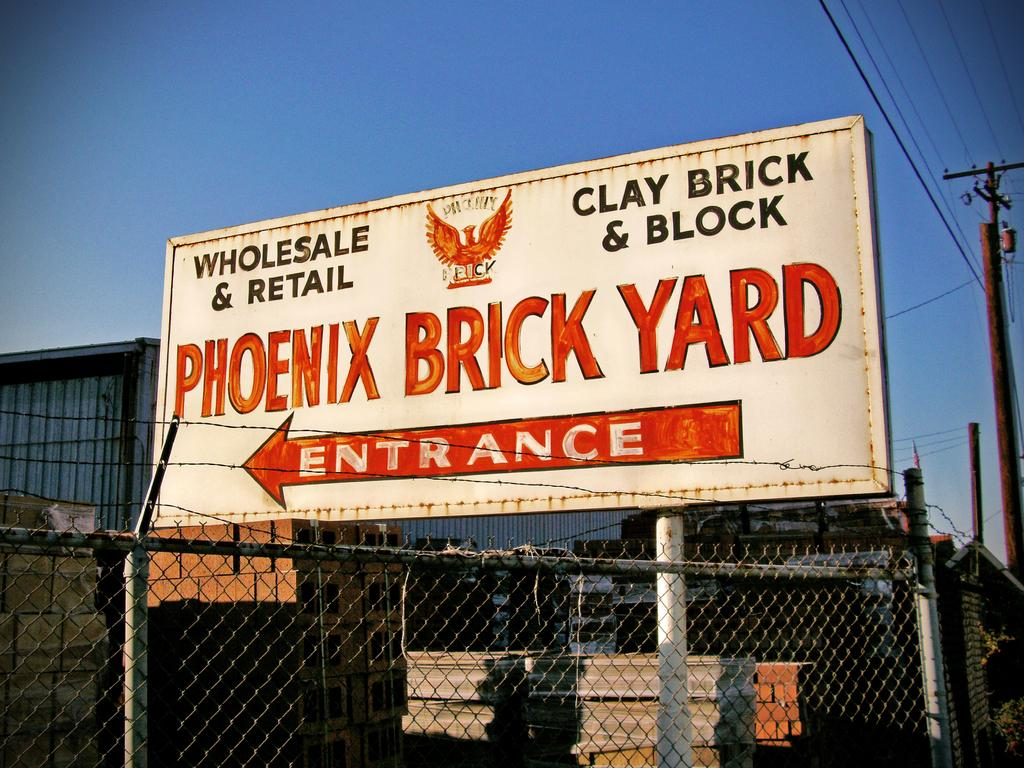<image>
Write a terse but informative summary of the picture. A Phoenix Brick yard Billboard shows where the entrance is with a big red arrow. 